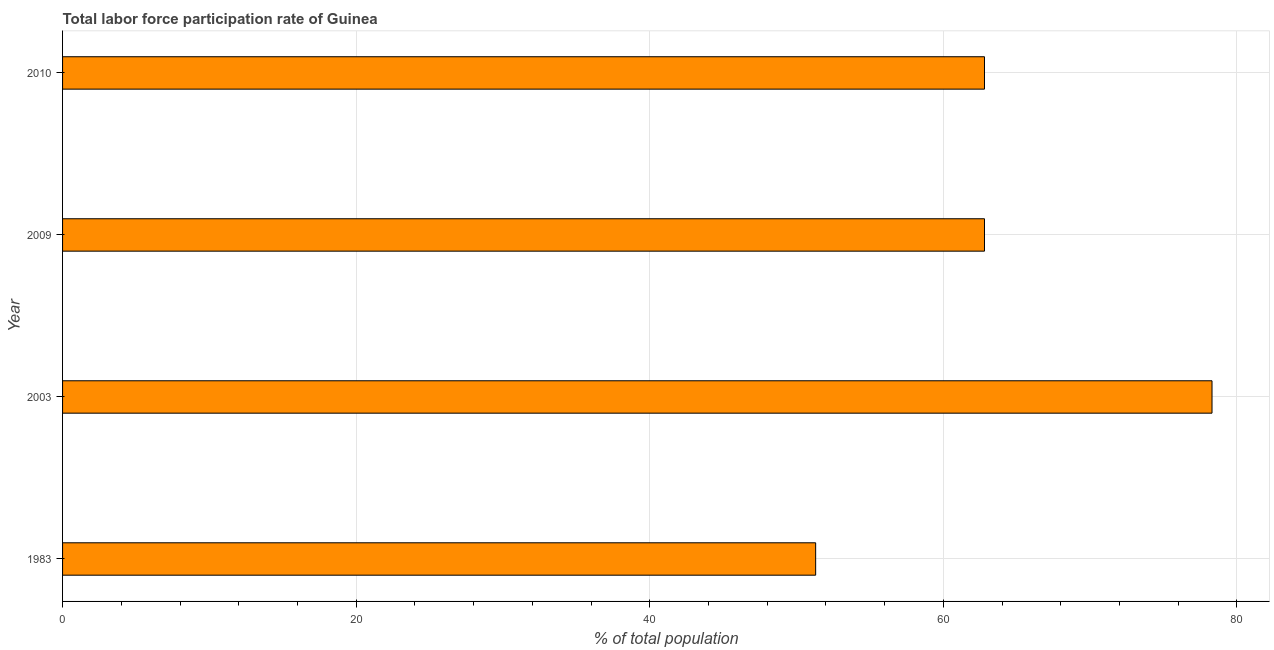What is the title of the graph?
Your answer should be compact. Total labor force participation rate of Guinea. What is the label or title of the X-axis?
Your response must be concise. % of total population. What is the total labor force participation rate in 2009?
Offer a very short reply. 62.8. Across all years, what is the maximum total labor force participation rate?
Offer a terse response. 78.3. Across all years, what is the minimum total labor force participation rate?
Give a very brief answer. 51.3. In which year was the total labor force participation rate maximum?
Offer a very short reply. 2003. In which year was the total labor force participation rate minimum?
Your response must be concise. 1983. What is the sum of the total labor force participation rate?
Your answer should be compact. 255.2. What is the average total labor force participation rate per year?
Give a very brief answer. 63.8. What is the median total labor force participation rate?
Your answer should be compact. 62.8. Do a majority of the years between 2009 and 1983 (inclusive) have total labor force participation rate greater than 16 %?
Your response must be concise. Yes. What is the ratio of the total labor force participation rate in 1983 to that in 2010?
Your answer should be compact. 0.82. Is the difference between the total labor force participation rate in 1983 and 2010 greater than the difference between any two years?
Ensure brevity in your answer.  No. What is the difference between the highest and the second highest total labor force participation rate?
Keep it short and to the point. 15.5. Is the sum of the total labor force participation rate in 2003 and 2009 greater than the maximum total labor force participation rate across all years?
Provide a short and direct response. Yes. What is the difference between the highest and the lowest total labor force participation rate?
Ensure brevity in your answer.  27. In how many years, is the total labor force participation rate greater than the average total labor force participation rate taken over all years?
Give a very brief answer. 1. Are all the bars in the graph horizontal?
Ensure brevity in your answer.  Yes. How many years are there in the graph?
Keep it short and to the point. 4. What is the difference between two consecutive major ticks on the X-axis?
Give a very brief answer. 20. What is the % of total population of 1983?
Your answer should be compact. 51.3. What is the % of total population in 2003?
Ensure brevity in your answer.  78.3. What is the % of total population in 2009?
Provide a short and direct response. 62.8. What is the % of total population in 2010?
Provide a short and direct response. 62.8. What is the difference between the % of total population in 1983 and 2003?
Your answer should be very brief. -27. What is the difference between the % of total population in 1983 and 2009?
Your answer should be very brief. -11.5. What is the difference between the % of total population in 2003 and 2009?
Offer a very short reply. 15.5. What is the difference between the % of total population in 2003 and 2010?
Offer a terse response. 15.5. What is the difference between the % of total population in 2009 and 2010?
Offer a very short reply. 0. What is the ratio of the % of total population in 1983 to that in 2003?
Your response must be concise. 0.66. What is the ratio of the % of total population in 1983 to that in 2009?
Offer a terse response. 0.82. What is the ratio of the % of total population in 1983 to that in 2010?
Your answer should be compact. 0.82. What is the ratio of the % of total population in 2003 to that in 2009?
Your answer should be compact. 1.25. What is the ratio of the % of total population in 2003 to that in 2010?
Keep it short and to the point. 1.25. What is the ratio of the % of total population in 2009 to that in 2010?
Give a very brief answer. 1. 